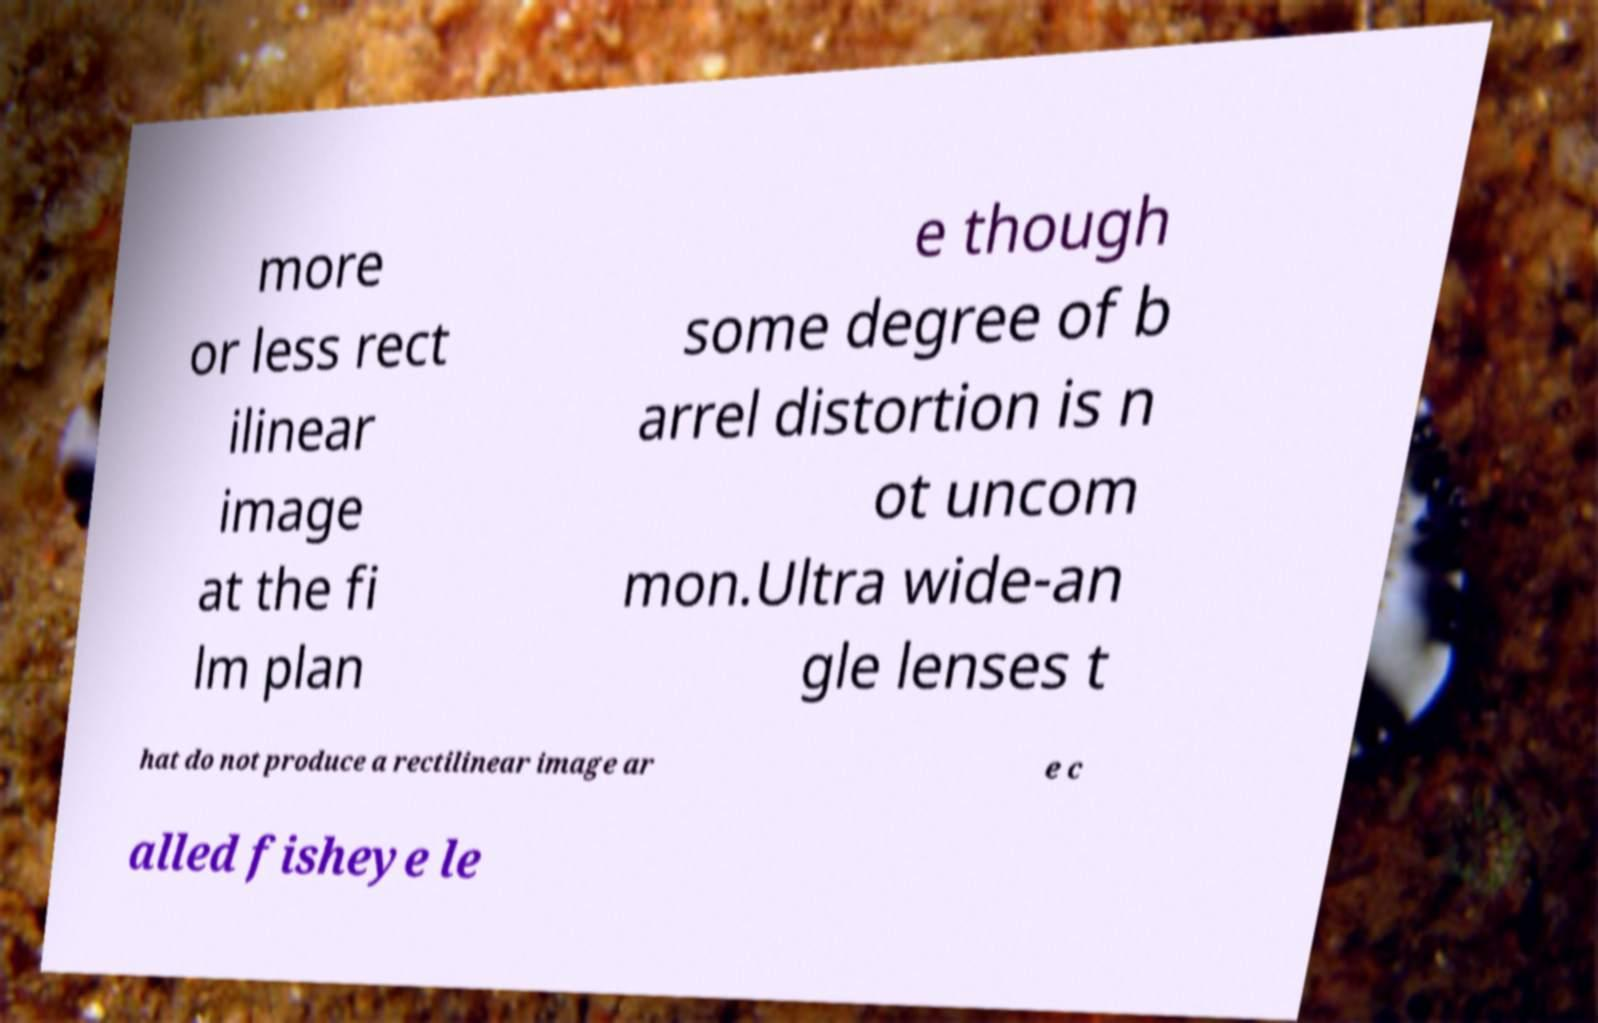Please read and relay the text visible in this image. What does it say? more or less rect ilinear image at the fi lm plan e though some degree of b arrel distortion is n ot uncom mon.Ultra wide-an gle lenses t hat do not produce a rectilinear image ar e c alled fisheye le 